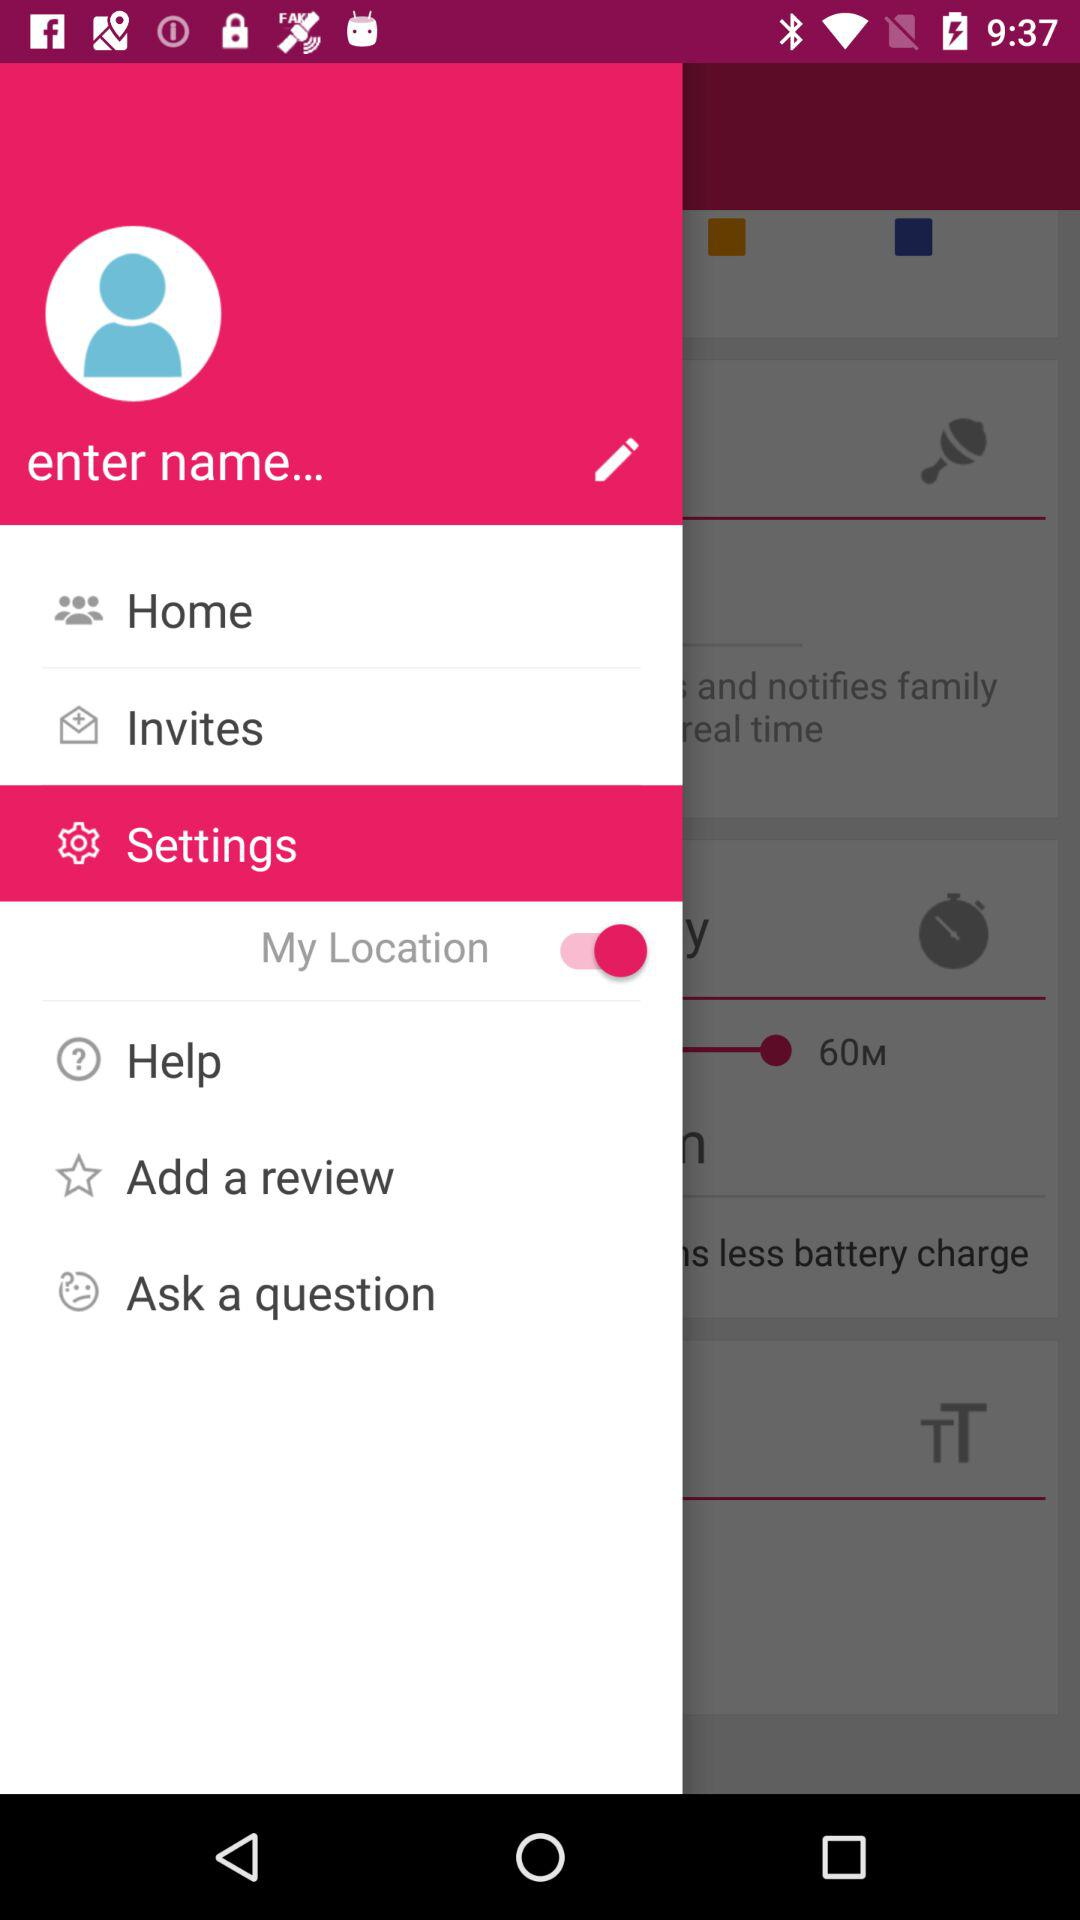When was the last review added?
When the provided information is insufficient, respond with <no answer>. <no answer> 